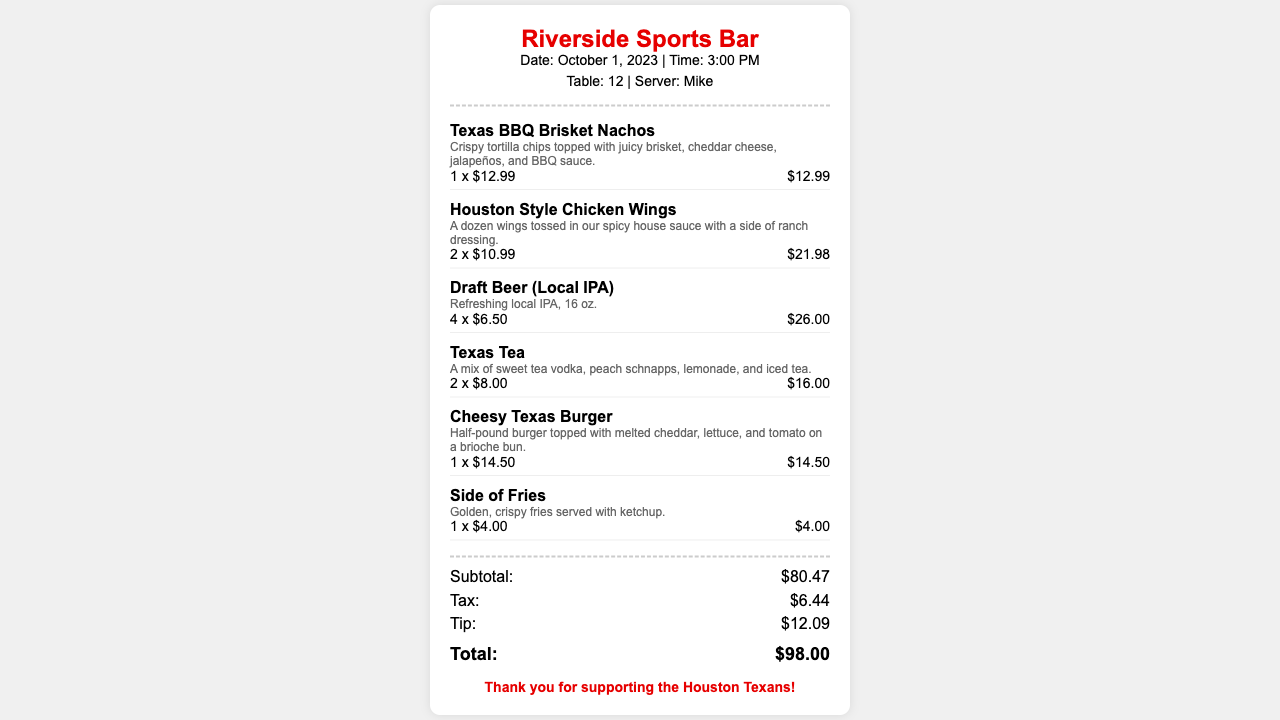What is the name of the restaurant? The name of the restaurant is indicated at the top of the receipt.
Answer: Riverside Sports Bar What item was ordered the most? The item that was ordered the most is the Houston Style Chicken Wings, which were ordered in quantities of two.
Answer: Houston Style Chicken Wings How much was the Texas BBQ Brisket Nachos? The price of the Texas BBQ Brisket Nachos is specified next to the item.
Answer: $12.99 What is the total amount paid? The total amount is summarized at the bottom of the receipt.
Answer: $98.00 What was the tax amount? The tax amount is clearly listed in the totals section of the receipt.
Answer: $6.44 How many beers were ordered? The quantity of draft beers ordered is noted next to the item.
Answer: 4 What was the date of the visit? The date is included in the header section of the receipt.
Answer: October 1, 2023 Who was the server? The name of the server is mentioned in the receipt details.
Answer: Mike What is included in the description of the Cheesy Texas Burger? The description includes details about the toppings and type of bun.
Answer: Half-pound burger topped with melted cheddar, lettuce, and tomato on a brioche bun 